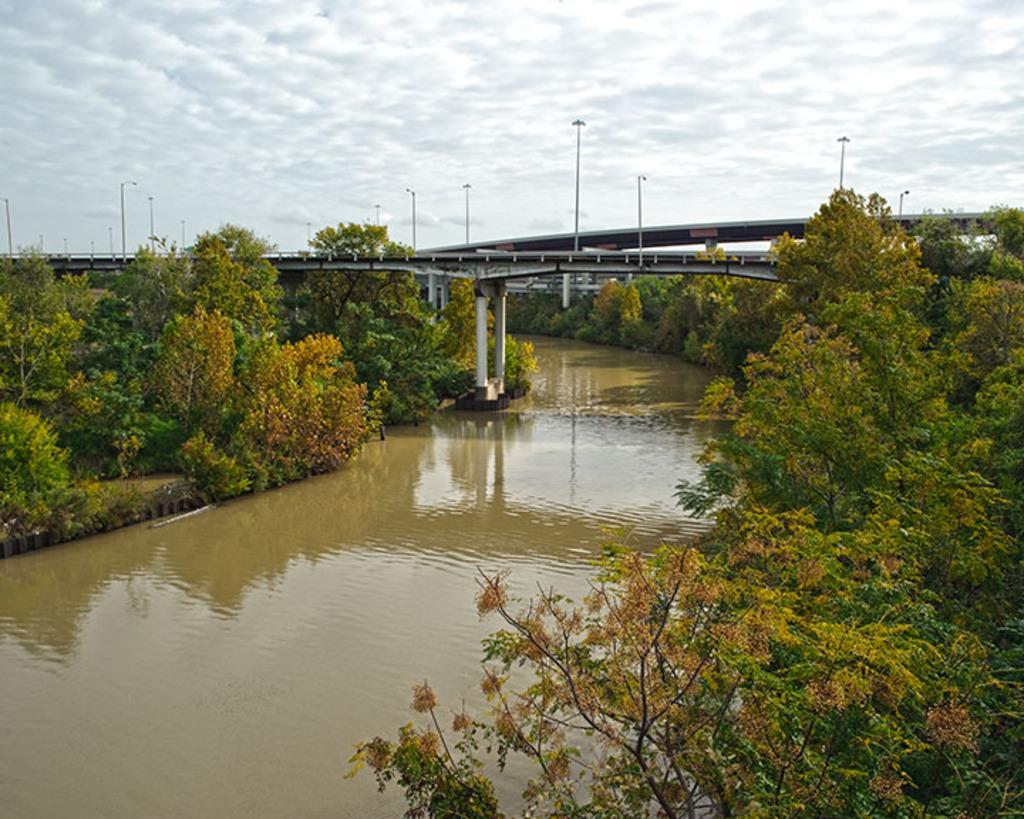Could you give a brief overview of what you see in this image? In this picture I can see there is a lake, trees, plants and a bridge here and there are few poles and the sky is clear. 